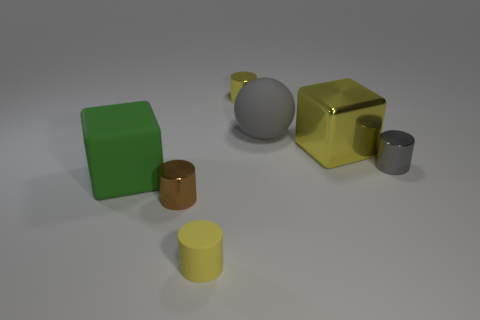Is there a small brown object that is behind the matte object that is in front of the big rubber cube?
Make the answer very short. Yes. What number of other things are there of the same shape as the brown shiny object?
Keep it short and to the point. 3. Do the green matte thing and the big metallic object have the same shape?
Your response must be concise. Yes. The matte object that is both right of the big green cube and in front of the small gray metal cylinder is what color?
Provide a short and direct response. Yellow. What is the size of the cylinder that is the same color as the tiny matte thing?
Provide a succinct answer. Small. How many tiny objects are either yellow shiny cylinders or rubber cubes?
Your answer should be very brief. 1. Is there any other thing of the same color as the big sphere?
Your answer should be compact. Yes. The big cube that is on the left side of the yellow cylinder that is in front of the tiny cylinder to the left of the tiny yellow matte object is made of what material?
Provide a short and direct response. Rubber. How many metallic objects are either large gray objects or brown cylinders?
Your answer should be compact. 1. How many yellow objects are either tiny shiny balls or big blocks?
Offer a terse response. 1. 